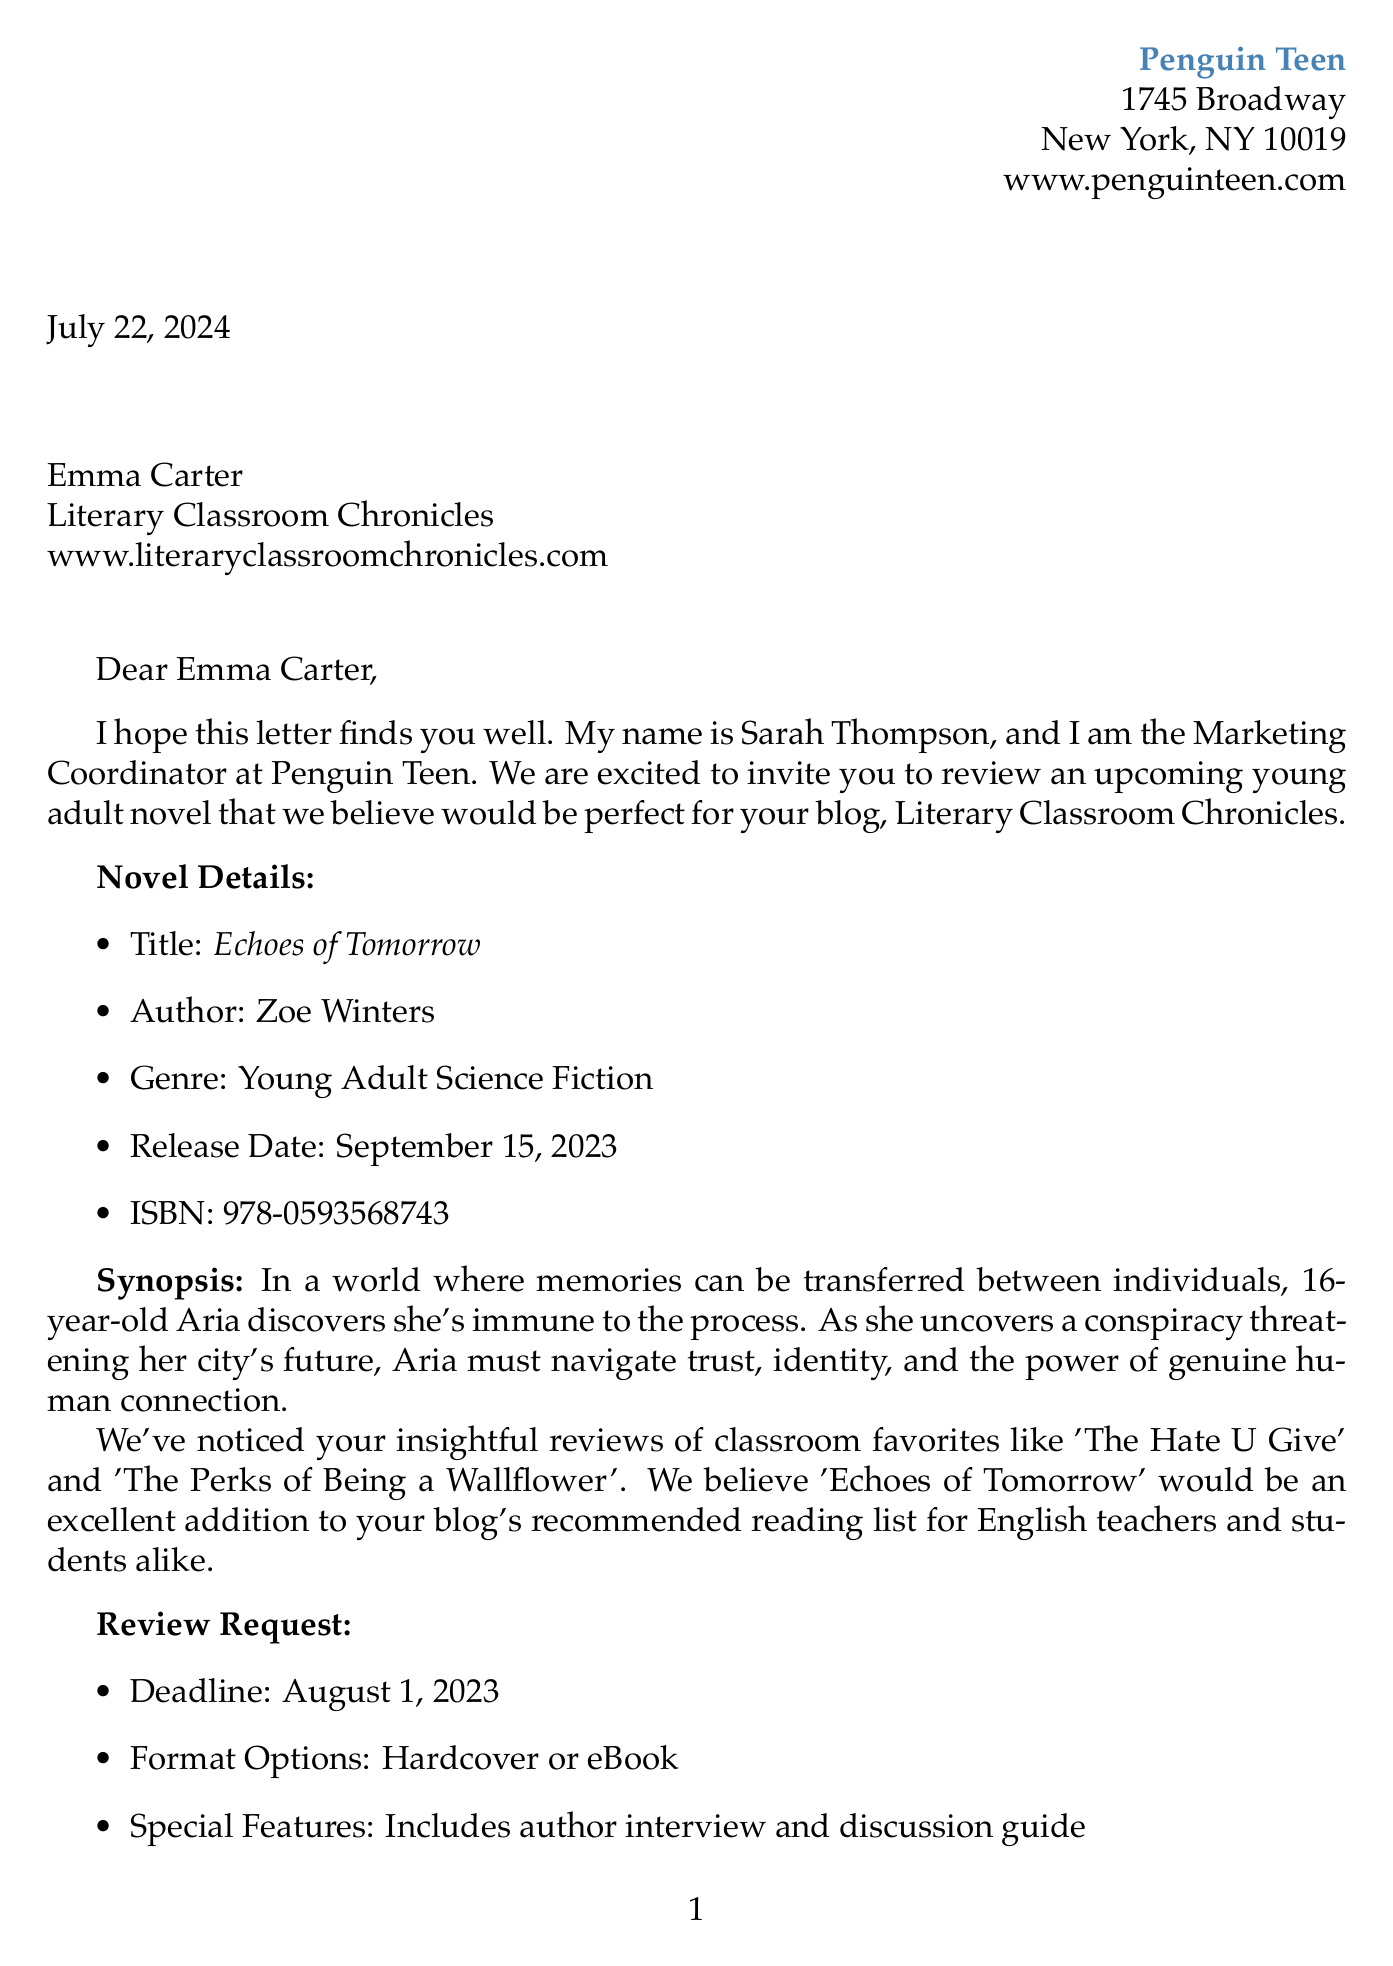What is the name of the publisher? The publisher's name is mentioned in the document as Penguin Teen.
Answer: Penguin Teen Who is the marketing coordinator? The document specifies that Sarah Thompson is the Marketing Coordinator at Penguin Teen.
Answer: Sarah Thompson What is the release date of the novel? The document states that the release date of the novel is September 15, 2023.
Answer: September 15, 2023 What are the format options available for the review copy? The document lists the format options as either Hardcover or eBook.
Answer: Hardcover or eBook What is the ISBN number of 'Echoes of Tomorrow'? The ISBN number is provided in the document as 978-0593568743.
Answer: 978-0593568743 What special features are included with the novel? The document mentions that the special features include an author interview and discussion guide.
Answer: Author interview and discussion guide What type of promotional opportunity is offered for the blog? The document highlights an exclusive author Q&A as one of the promotional opportunities.
Answer: Exclusive author Q&A Why is 'Echoes of Tomorrow' relevant to the high school curriculum? The document describes the novel's themes as aligning with high school English curriculum on social issues and ethics.
Answer: Social issues and ethics What is the deadline for the review submission? The document specifies that the deadline for the review submission is August 1, 2023.
Answer: August 1, 2023 